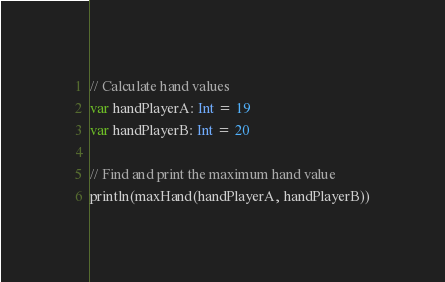Convert code to text. <code><loc_0><loc_0><loc_500><loc_500><_Scala_>// Calculate hand values
var handPlayerA: Int = 19
var handPlayerB: Int = 20

// Find and print the maximum hand value
println(maxHand(handPlayerA, handPlayerB))</code> 